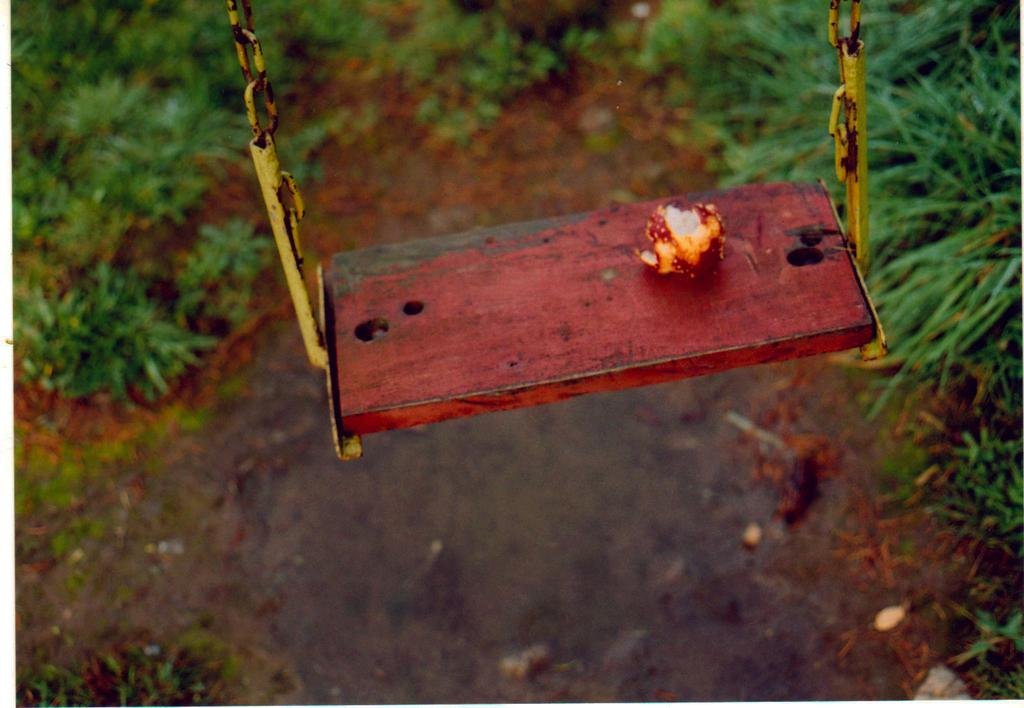What is the main subject of the picture? The main subject of the picture is a fruit. What is the fruit doing in the image? The fruit is on a swing. What can be seen in the background of the image? There is grass visible in the background of the image. Where is the grass located in relation to the fruit? The grass is on the ground in the background. What type of feast is being prepared in the image? There is no indication of a feast or any food preparation in the image; it features a fruit on a swing with grass in the background. Can you see any worms interacting with the fruit in the image? There are no worms visible in the image; it only shows a fruit on a swing and grass in the background. 